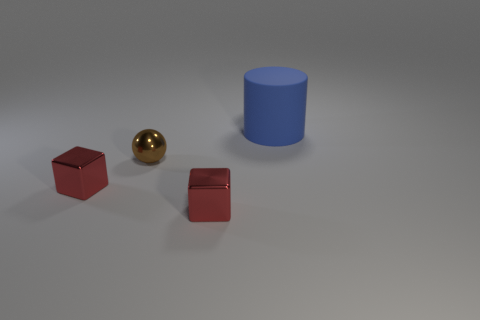What number of things are things in front of the matte cylinder or metallic balls?
Offer a very short reply. 3. Is the number of big blue matte cylinders in front of the tiny metallic ball the same as the number of big cyan things?
Offer a terse response. Yes. Do the ball and the cylinder that is behind the brown metal ball have the same size?
Offer a very short reply. No. What number of objects are either small red blocks or objects that are left of the blue matte cylinder?
Give a very brief answer. 3. There is a red thing on the right side of the brown ball; is its size the same as the blue object that is on the right side of the brown sphere?
Give a very brief answer. No. Are there any other objects made of the same material as the brown object?
Offer a terse response. Yes. There is a small brown object; what shape is it?
Ensure brevity in your answer.  Sphere. There is a object that is in front of the small red metal thing left of the tiny brown shiny thing; what shape is it?
Offer a very short reply. Cube. What number of other things are the same shape as the tiny brown thing?
Give a very brief answer. 0. There is a shiny cube right of the small metallic cube left of the brown metallic object; what is its size?
Your response must be concise. Small. 